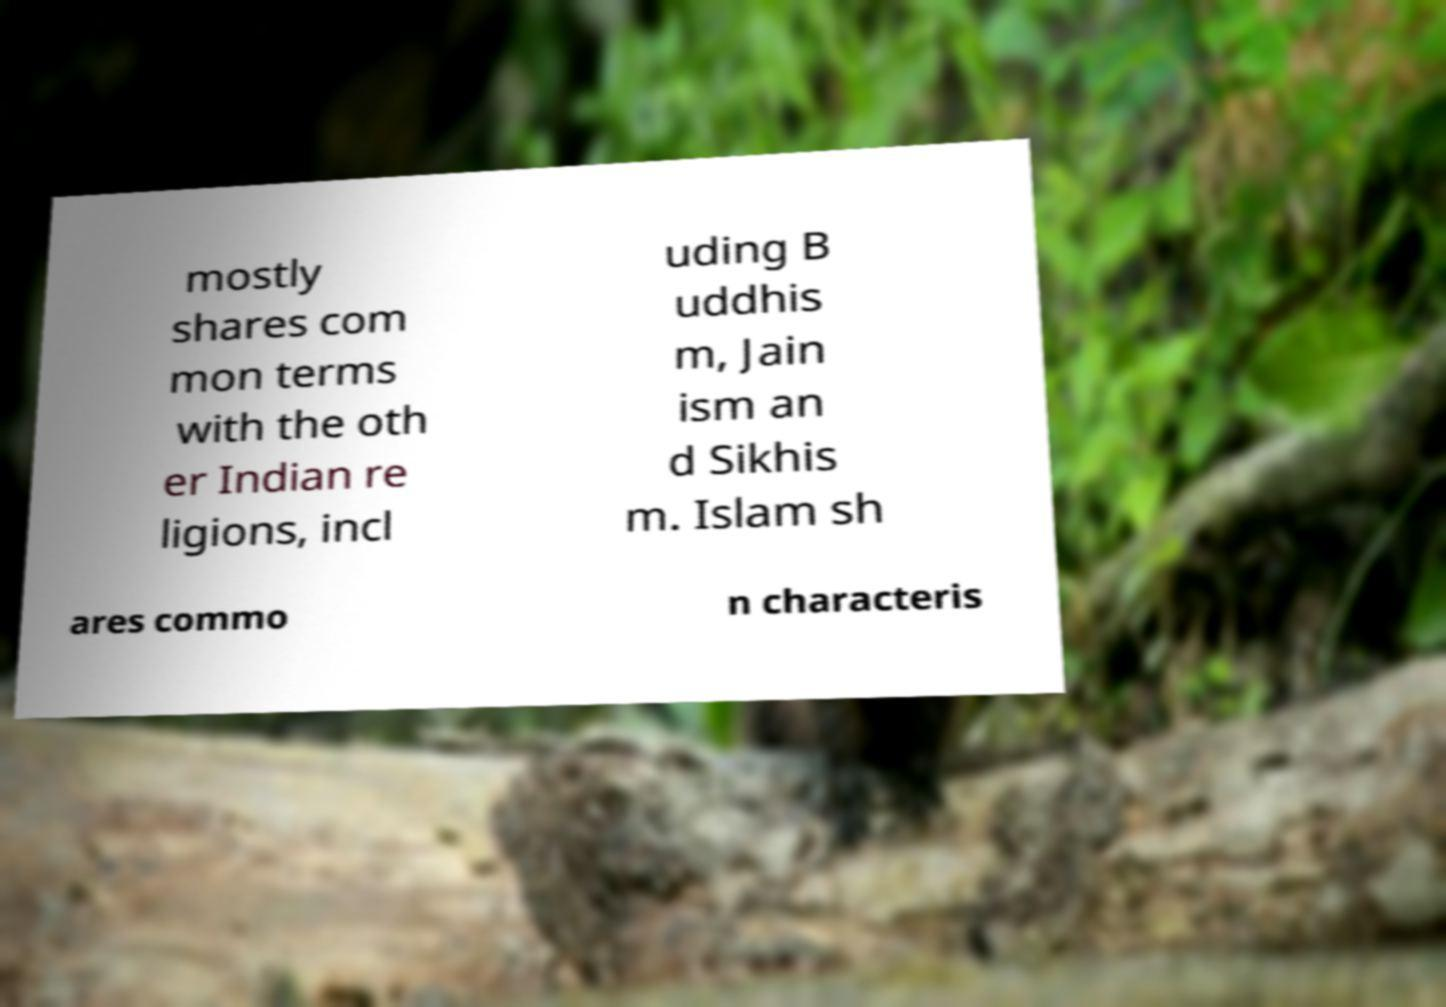What messages or text are displayed in this image? I need them in a readable, typed format. mostly shares com mon terms with the oth er Indian re ligions, incl uding B uddhis m, Jain ism an d Sikhis m. Islam sh ares commo n characteris 